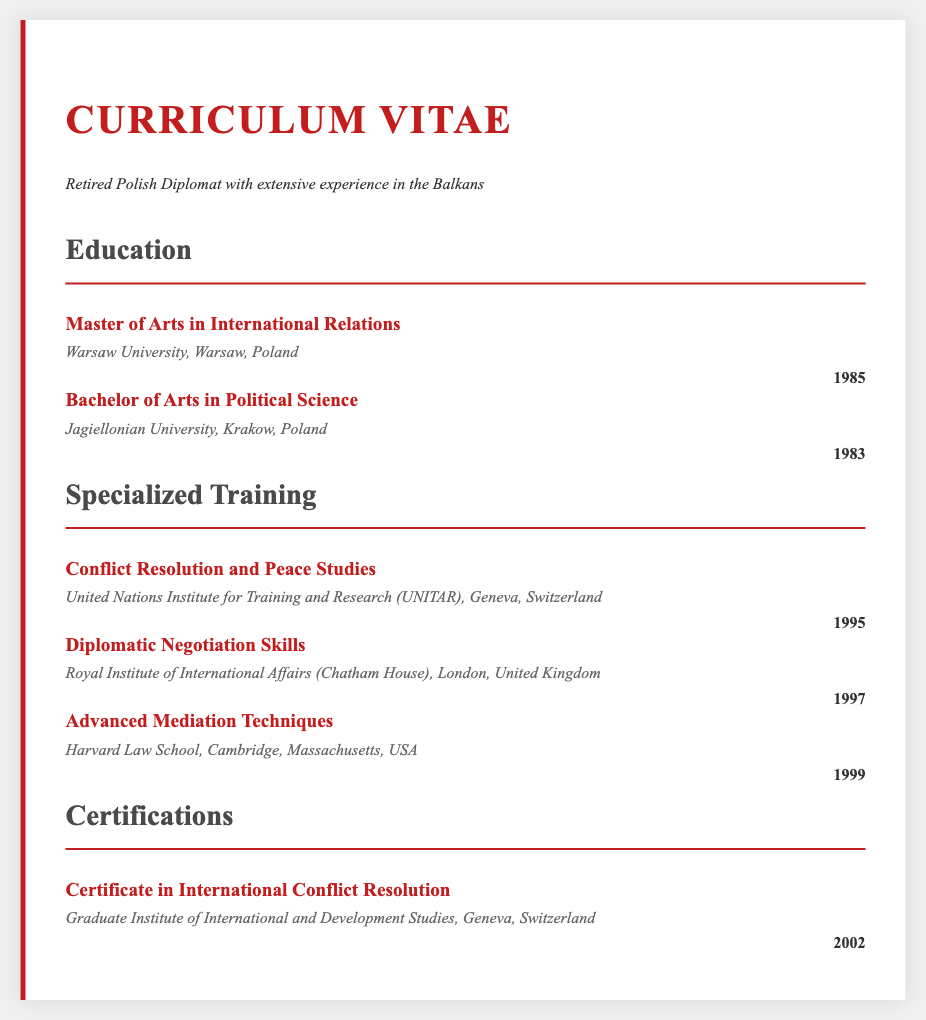what degree was obtained in 1985? The document states that the "Master of Arts in International Relations" was obtained in 1985.
Answer: Master of Arts in International Relations which university awarded the Bachelor's degree? The Bachelor's degree was awarded by Jagiellonian University, as mentioned in the document.
Answer: Jagiellonian University what specialized training was completed in 1995? The "Conflict Resolution and Peace Studies" training was completed in 1995, according to the document.
Answer: Conflict Resolution and Peace Studies how many years apart were the Bachelor's and Master's degrees? The Bachelor's degree was obtained in 1983 and the Master's in 1985, which is a 2-year difference.
Answer: 2 years which institution provided specialized training in diplomatic negotiation? The training in diplomatic negotiation skills was provided by the Royal Institute of International Affairs (Chatham House).
Answer: Royal Institute of International Affairs (Chatham House) what is the title of the certification received in 2002? The title of the certification received in 2002 is "Certificate in International Conflict Resolution".
Answer: Certificate in International Conflict Resolution who completed advanced mediation techniques training? The retired Polish diplomat is the individual who completed the advanced mediation techniques training as stated in the document.
Answer: Retired Polish Diplomat which year did the individual start specialized training? The first specialized training listed, "Conflict Resolution and Peace Studies," started in 1995, indicating that year as the start for specialized training.
Answer: 1995 what major field does the education focus on? The education focuses on International Relations, as highlighted by the Master's degree mentioned in the document.
Answer: International Relations 